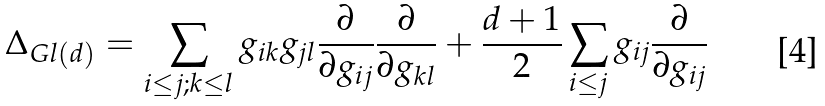Convert formula to latex. <formula><loc_0><loc_0><loc_500><loc_500>\Delta _ { G l ( d ) } = \sum _ { i \leq j ; k \leq l } g _ { i k } g _ { j l } \frac { \partial } { \partial g _ { i j } } \frac { \partial } { \partial g _ { k l } } + \frac { d + 1 } { 2 } \sum _ { i \leq j } g _ { i j } \frac { \partial } { \partial g _ { i j } }</formula> 